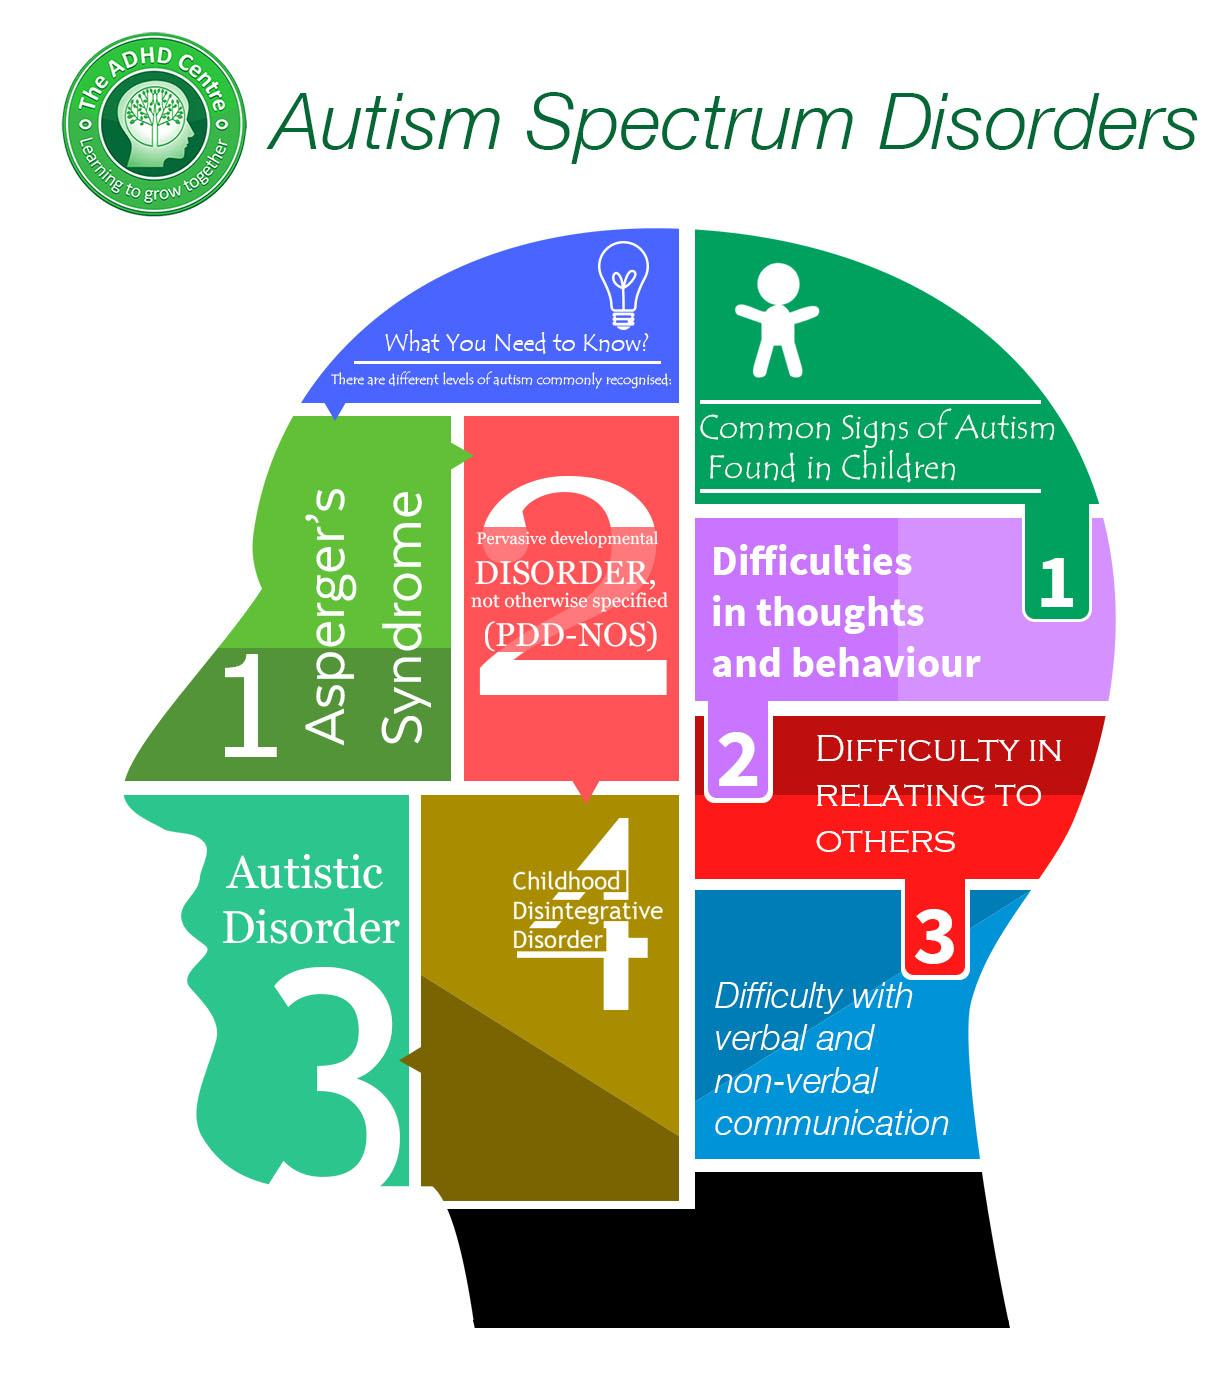Specify some key components in this picture. Childhood disintegrative disorder is the fourth level of autism mentioned. Autism is characterized by three key signs in children, including difficulty in relating to others. 